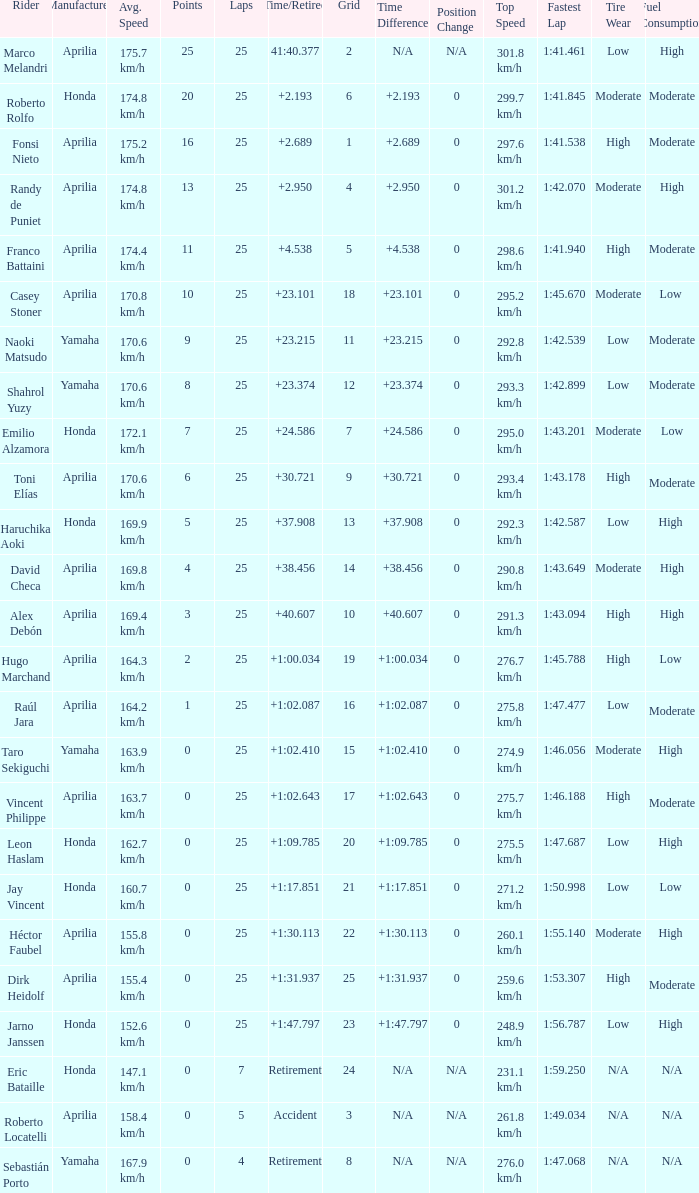Which Laps have a Time/Retired of +23.215, and a Grid larger than 11? None. 